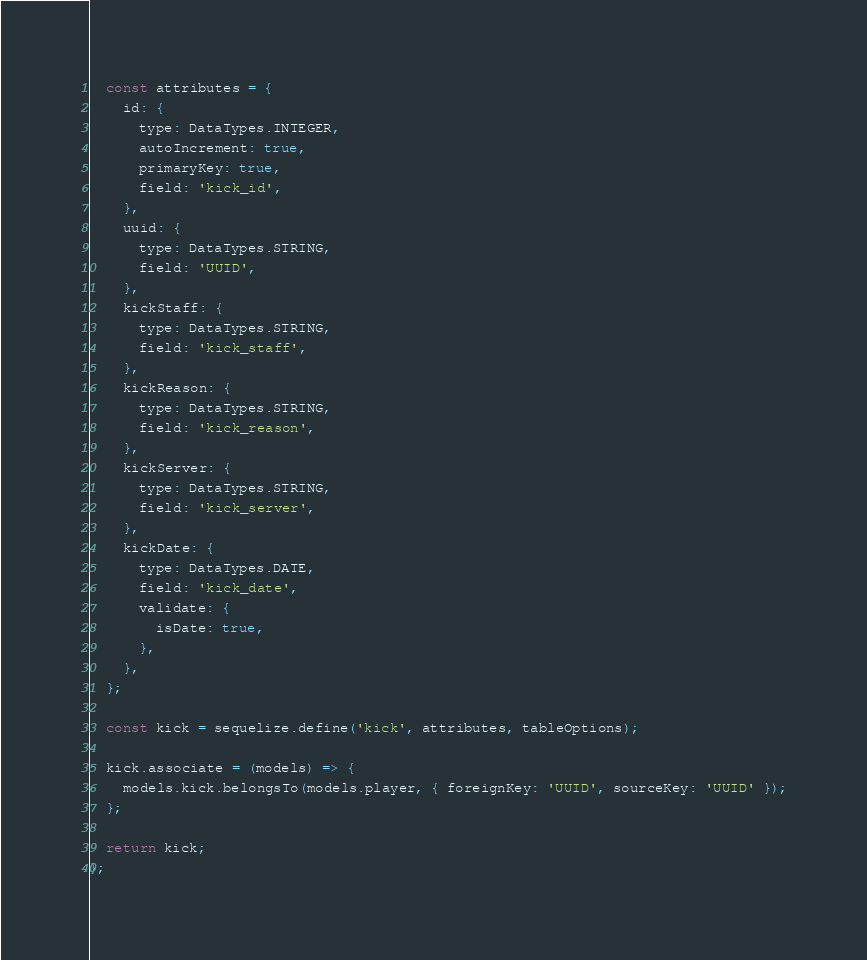<code> <loc_0><loc_0><loc_500><loc_500><_JavaScript_>
  const attributes = {
    id: {
      type: DataTypes.INTEGER,
      autoIncrement: true,
      primaryKey: true,
      field: 'kick_id',
    },
    uuid: {
      type: DataTypes.STRING,
      field: 'UUID',
    },
    kickStaff: {
      type: DataTypes.STRING,
      field: 'kick_staff',
    },
    kickReason: {
      type: DataTypes.STRING,
      field: 'kick_reason',
    },
    kickServer: {
      type: DataTypes.STRING,
      field: 'kick_server',
    },
    kickDate: {
      type: DataTypes.DATE,
      field: 'kick_date',
      validate: {
        isDate: true,
      },
    },
  };

  const kick = sequelize.define('kick', attributes, tableOptions);

  kick.associate = (models) => {
    models.kick.belongsTo(models.player, { foreignKey: 'UUID', sourceKey: 'UUID' });
  };

  return kick;
};
</code> 